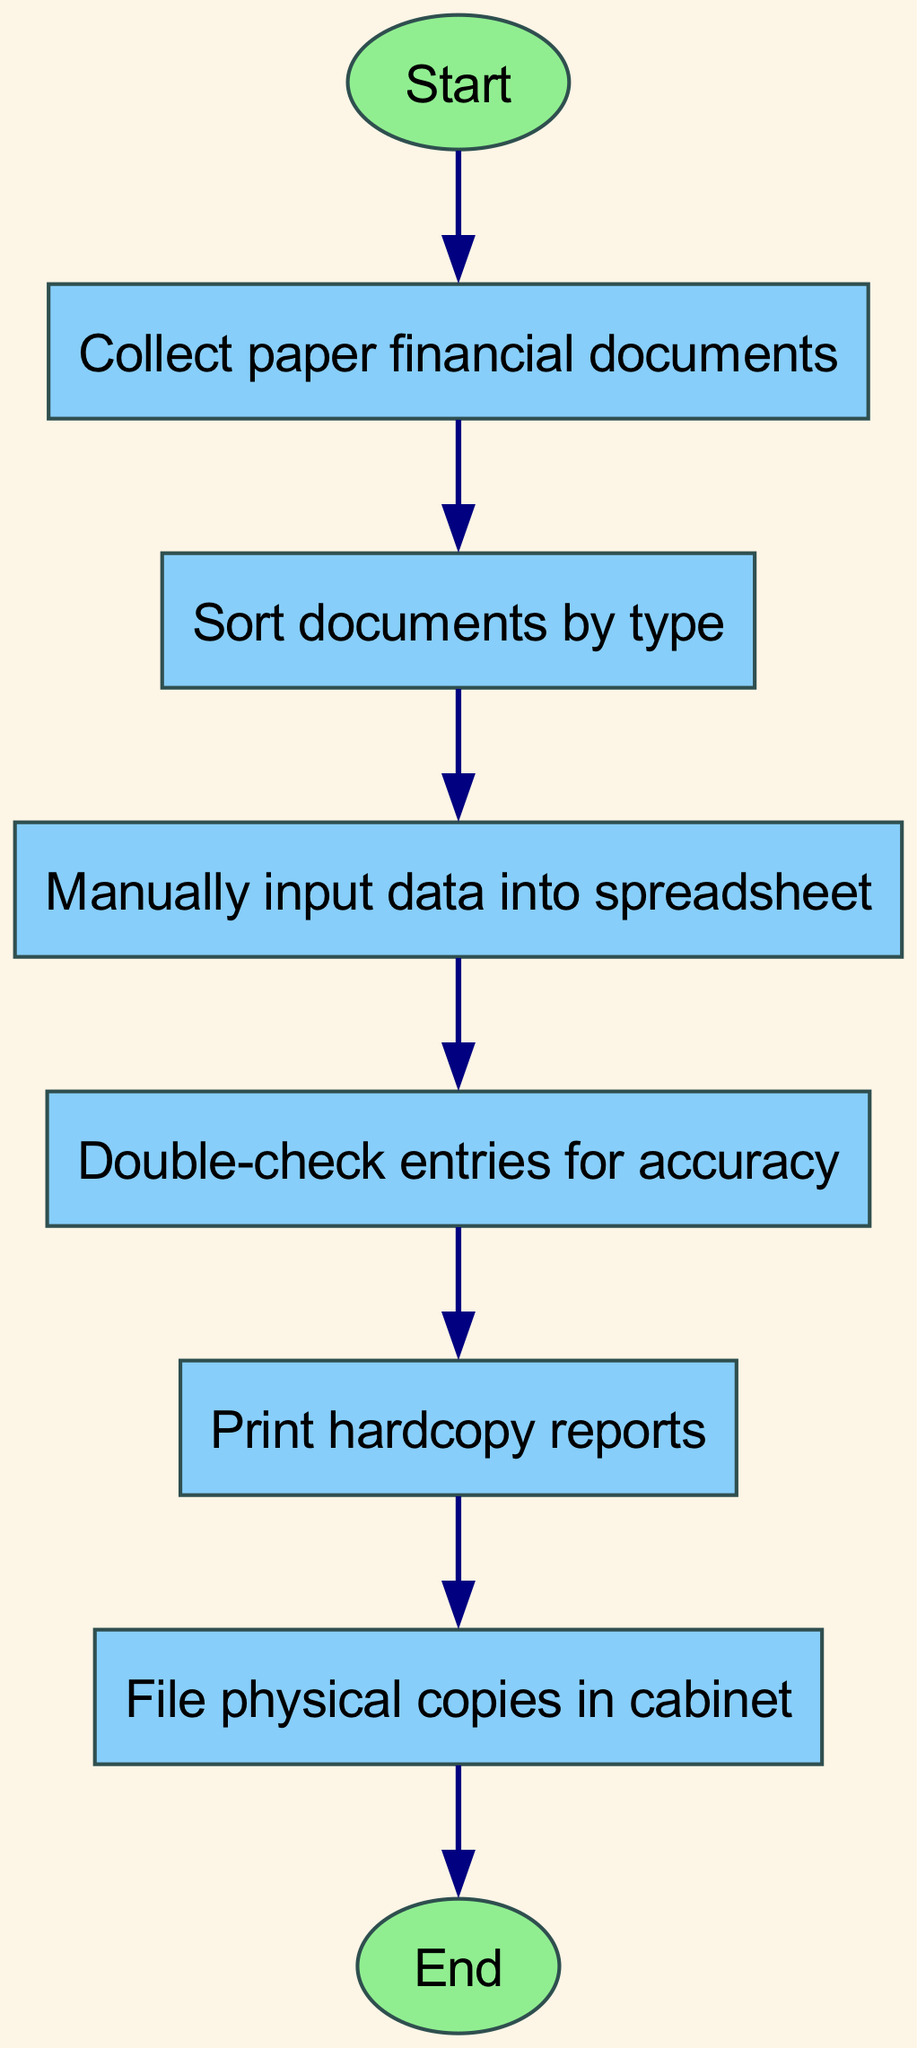What is the first step in the workflow? The workflow starts with the "Start" node, which initiates the process. From there, the first action is to "Collect paper financial documents."
Answer: Collect paper financial documents How many nodes are present in the diagram? To find the number of nodes, we count each unique task represented in the diagram. There are eight nodes: Start, Collect paper financial documents, Sort documents by type, Manually input data into spreadsheet, Double-check entries for accuracy, Print hardcopy reports, File physical copies in cabinet, and End.
Answer: Eight What comes after sorting documents? After sorting documents, the next step in the workflow is to "Manually input data into spreadsheet." This can be determined by following the flow from "Sort documents by type" to "Manually input data into spreadsheet."
Answer: Manually input data into spreadsheet What is the final action before the workflow ends? The last action in the workflow before reaching the "End" node is to "File physical copies in cabinet." This means filing the physical copies happens just before the process concludes.
Answer: File physical copies in cabinet Are there any decision nodes in this workflow? This flowchart does not contain any decision nodes as it follows a linear sequence of actions without alternative paths or branching conditions.
Answer: No Which action requires verification? The action that requires verification is "Double-check entries for accuracy." This action is specifically aimed at ensuring the data entered is correct.
Answer: Double-check entries for accuracy How many edges are present in the diagram? To find the number of edges, we count the arrows connecting the nodes. Each connection represents a directed edge, and there are seven edges that show transitions between actions.
Answer: Seven What is the purpose of printing hardcopy reports? The "Print hardcopy reports" step serves to create physical copies of the processed financial data, making it accessible for traditional documentation purposes.
Answer: To create physical copies of reports 